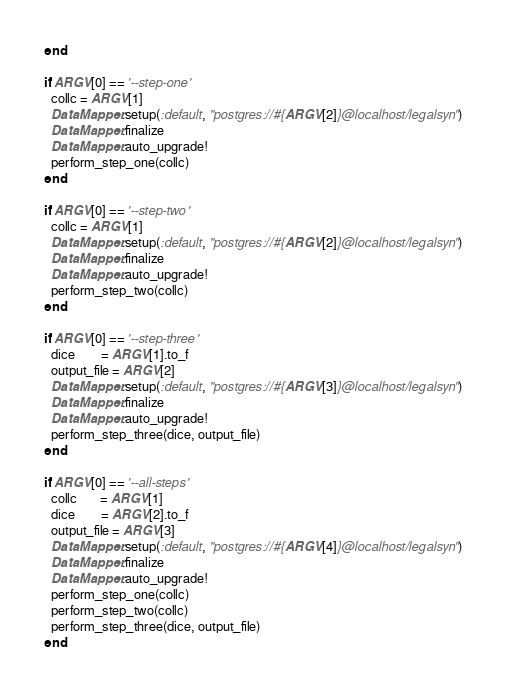<code> <loc_0><loc_0><loc_500><loc_500><_Ruby_>end

if ARGV[0] == '--step-one'
  collc = ARGV[1]
  DataMapper.setup(:default, "postgres://#{ARGV[2]}@localhost/legalsyn")
  DataMapper.finalize
  DataMapper.auto_upgrade!
  perform_step_one(collc)
end

if ARGV[0] == '--step-two'
  collc = ARGV[1]
  DataMapper.setup(:default, "postgres://#{ARGV[2]}@localhost/legalsyn")
  DataMapper.finalize
  DataMapper.auto_upgrade!
  perform_step_two(collc)
end

if ARGV[0] == '--step-three'
  dice        = ARGV[1].to_f
  output_file = ARGV[2]
  DataMapper.setup(:default, "postgres://#{ARGV[3]}@localhost/legalsyn")
  DataMapper.finalize
  DataMapper.auto_upgrade!
  perform_step_three(dice, output_file)
end

if ARGV[0] == '--all-steps'
  collc       = ARGV[1]
  dice        = ARGV[2].to_f
  output_file = ARGV[3]
  DataMapper.setup(:default, "postgres://#{ARGV[4]}@localhost/legalsyn")
  DataMapper.finalize
  DataMapper.auto_upgrade!
  perform_step_one(collc)
  perform_step_two(collc)
  perform_step_three(dice, output_file)
end</code> 